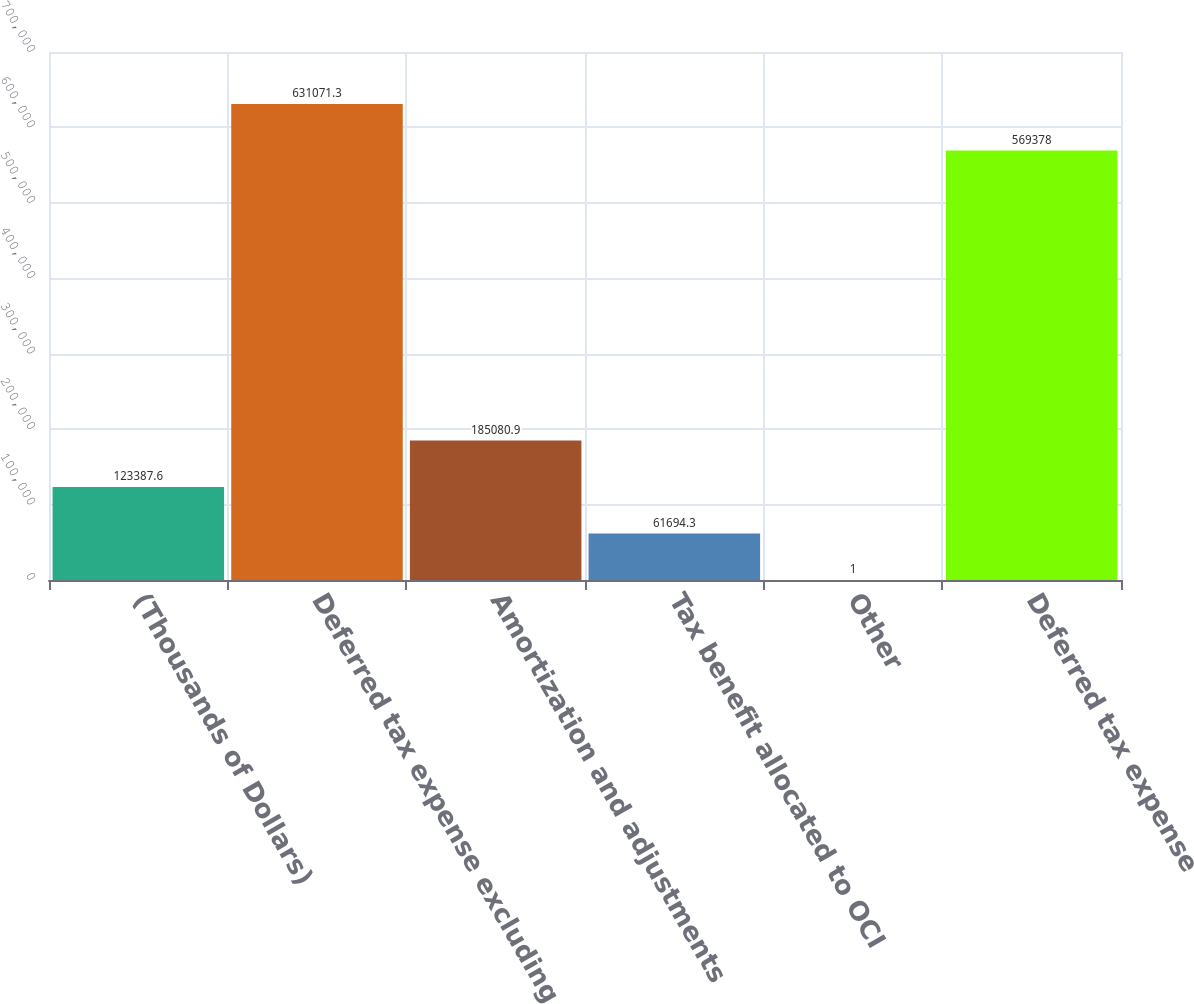<chart> <loc_0><loc_0><loc_500><loc_500><bar_chart><fcel>(Thousands of Dollars)<fcel>Deferred tax expense excluding<fcel>Amortization and adjustments<fcel>Tax benefit allocated to OCI<fcel>Other<fcel>Deferred tax expense<nl><fcel>123388<fcel>631071<fcel>185081<fcel>61694.3<fcel>1<fcel>569378<nl></chart> 